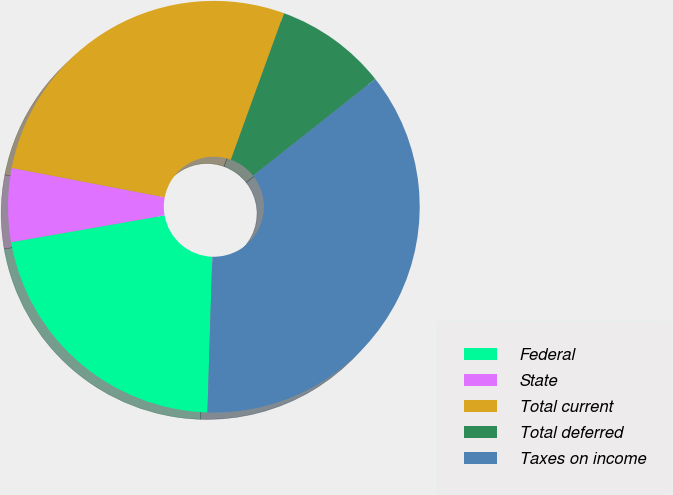Convert chart to OTSL. <chart><loc_0><loc_0><loc_500><loc_500><pie_chart><fcel>Federal<fcel>State<fcel>Total current<fcel>Total deferred<fcel>Taxes on income<nl><fcel>21.75%<fcel>5.77%<fcel>27.52%<fcel>8.81%<fcel>36.15%<nl></chart> 